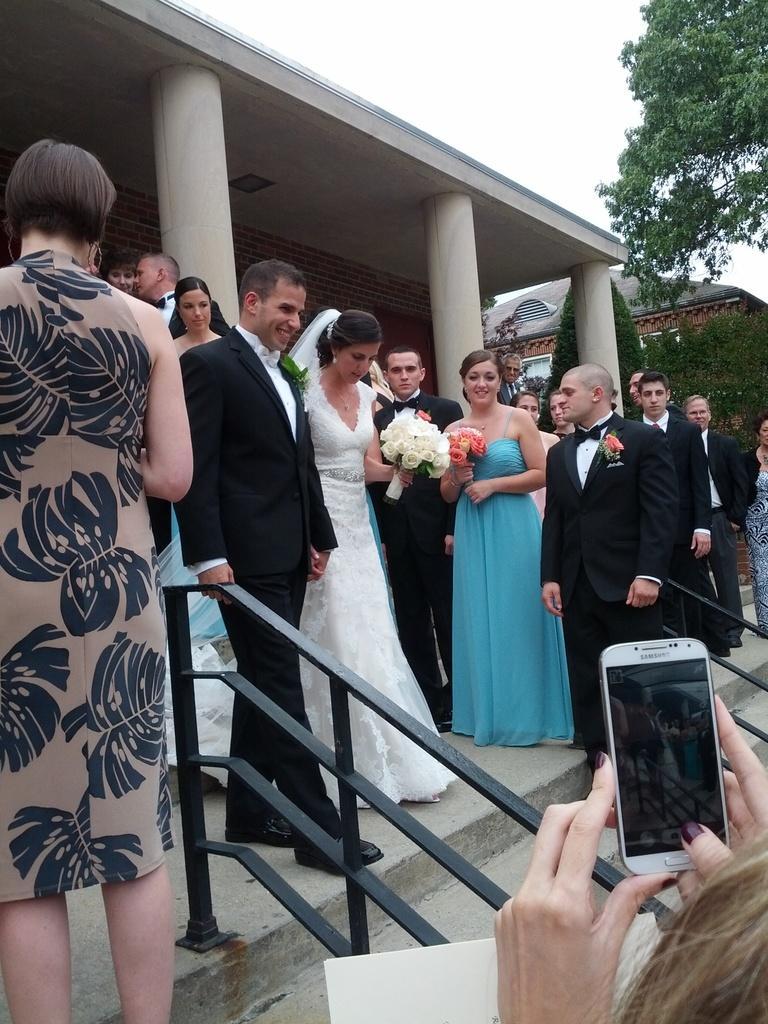Please provide a concise description of this image. A newly married couple are walking out. There are some people around them. A woman is taking their picture with a mobile in her hand. 